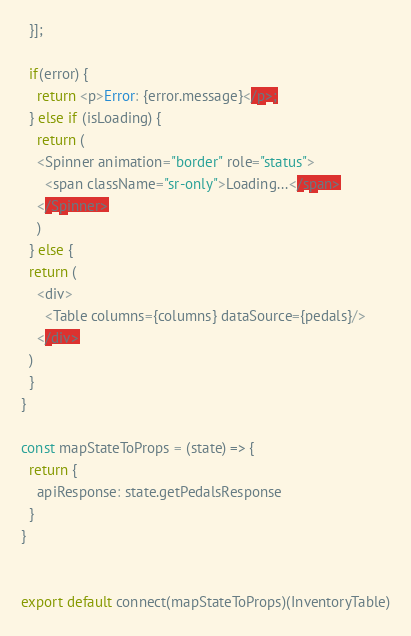<code> <loc_0><loc_0><loc_500><loc_500><_JavaScript_>  }];
  
  if(error) {
    return <p>Error: {error.message}</p>;
  } else if (isLoading) {
    return (
    <Spinner animation="border" role="status">
      <span className="sr-only">Loading...</span>
    </Spinner>
    )
  } else {
  return (
    <div>
      <Table columns={columns} dataSource={pedals}/>
    </div>
  )
  }
}

const mapStateToProps = (state) => {
  return {
    apiResponse: state.getPedalsResponse
  }
}


export default connect(mapStateToProps)(InventoryTable)
</code> 